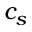Convert formula to latex. <formula><loc_0><loc_0><loc_500><loc_500>c _ { s }</formula> 